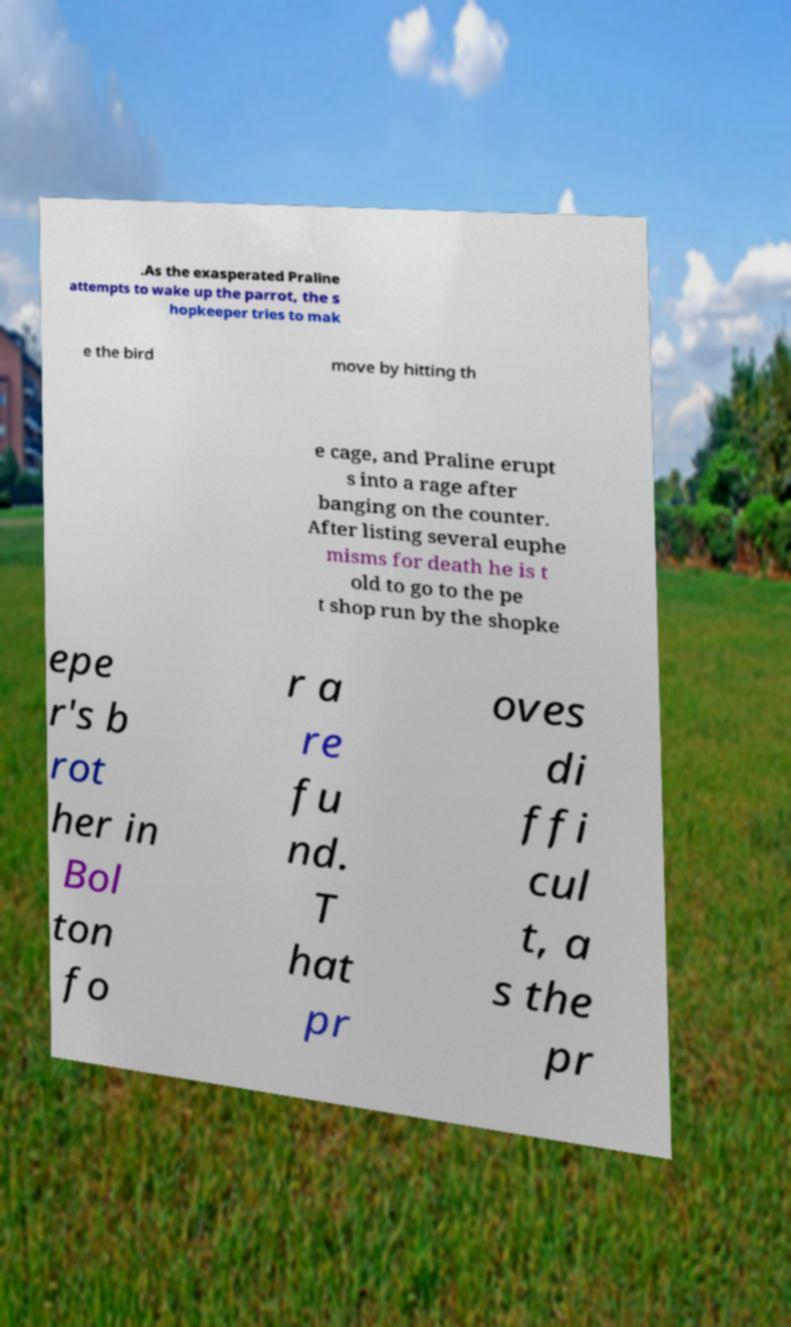I need the written content from this picture converted into text. Can you do that? .As the exasperated Praline attempts to wake up the parrot, the s hopkeeper tries to mak e the bird move by hitting th e cage, and Praline erupt s into a rage after banging on the counter. After listing several euphe misms for death he is t old to go to the pe t shop run by the shopke epe r's b rot her in Bol ton fo r a re fu nd. T hat pr oves di ffi cul t, a s the pr 